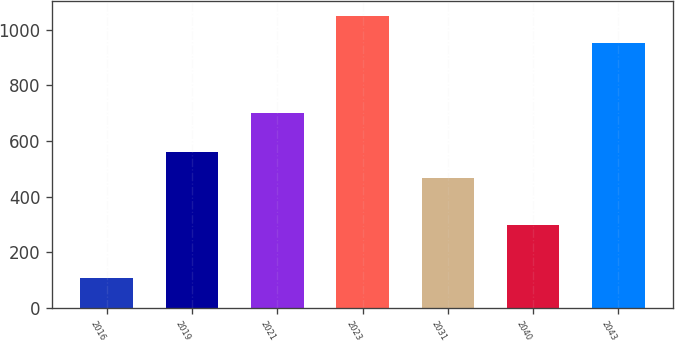Convert chart. <chart><loc_0><loc_0><loc_500><loc_500><bar_chart><fcel>2016<fcel>2019<fcel>2021<fcel>2023<fcel>2031<fcel>2040<fcel>2043<nl><fcel>107<fcel>560.3<fcel>700<fcel>1050<fcel>466<fcel>300<fcel>950<nl></chart> 